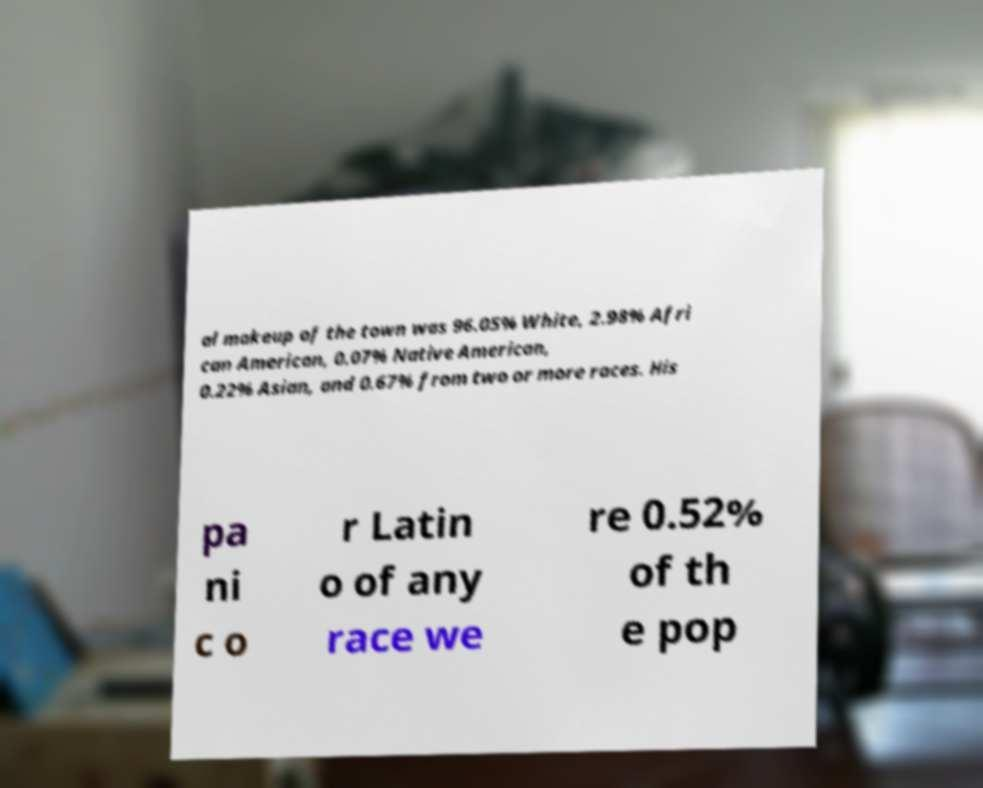Please read and relay the text visible in this image. What does it say? al makeup of the town was 96.05% White, 2.98% Afri can American, 0.07% Native American, 0.22% Asian, and 0.67% from two or more races. His pa ni c o r Latin o of any race we re 0.52% of th e pop 